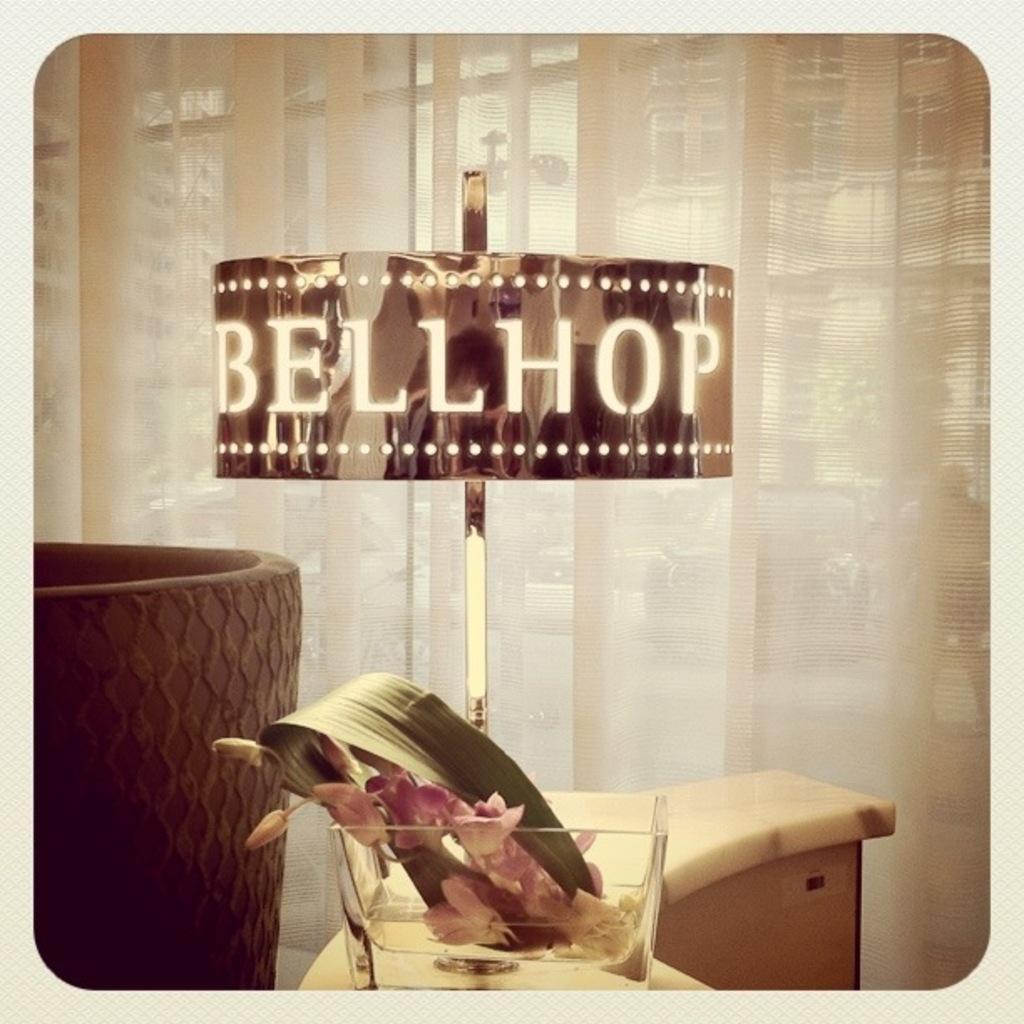How would you summarize this image in a sentence or two? In this image on the left side there is a couch, and at the bottom there is a desk. On the desk there is one box, in that box there are some flowers and in the center there is one board. On the board there is some text, and in the background there is a window and curtain and through the window we could see some vehicles, buildings and a tree. 